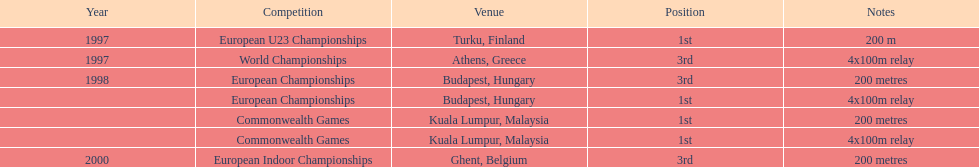How many 4x 100m relay competitions occurred? 3. 